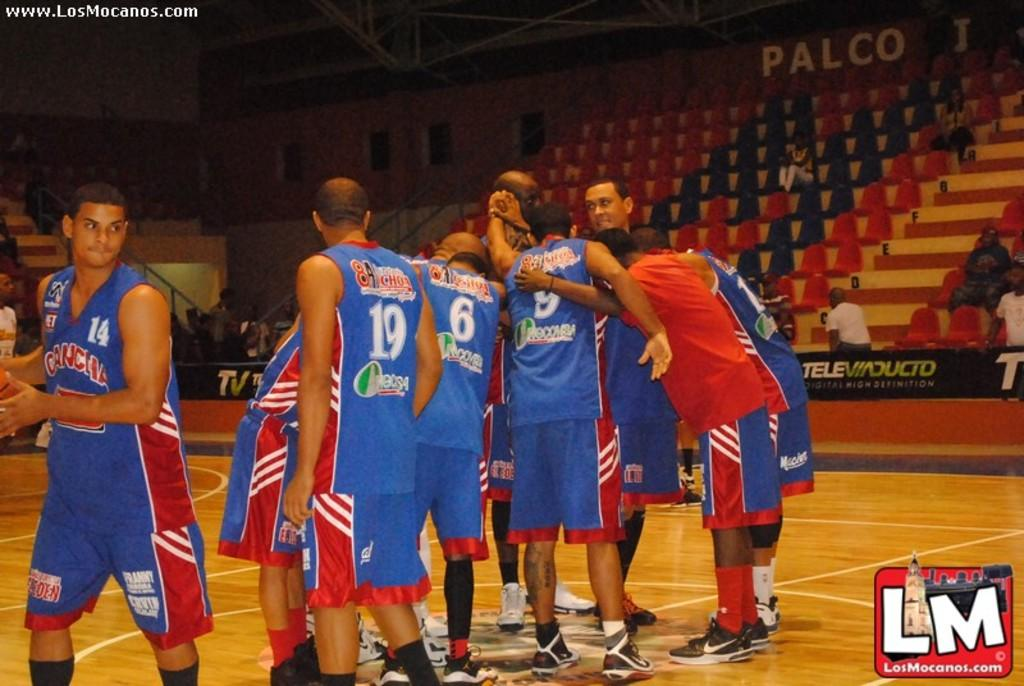What is the main subject of the image? The main subject of the image is people in the center. Can you identify any specific location or setting in the image? Yes, there appears to be a stadium in the top left corner of the image. Is there any text present in the image? Yes, there is some text visible in the right bottom corner of the image. What type of trick can be seen performed by the volcano in the image? There is no volcano present in the image, and therefore no trick can be observed. Can you describe the partner of the person in the image? There is no person or partner mentioned in the provided facts, so it is not possible to describe a partner. 